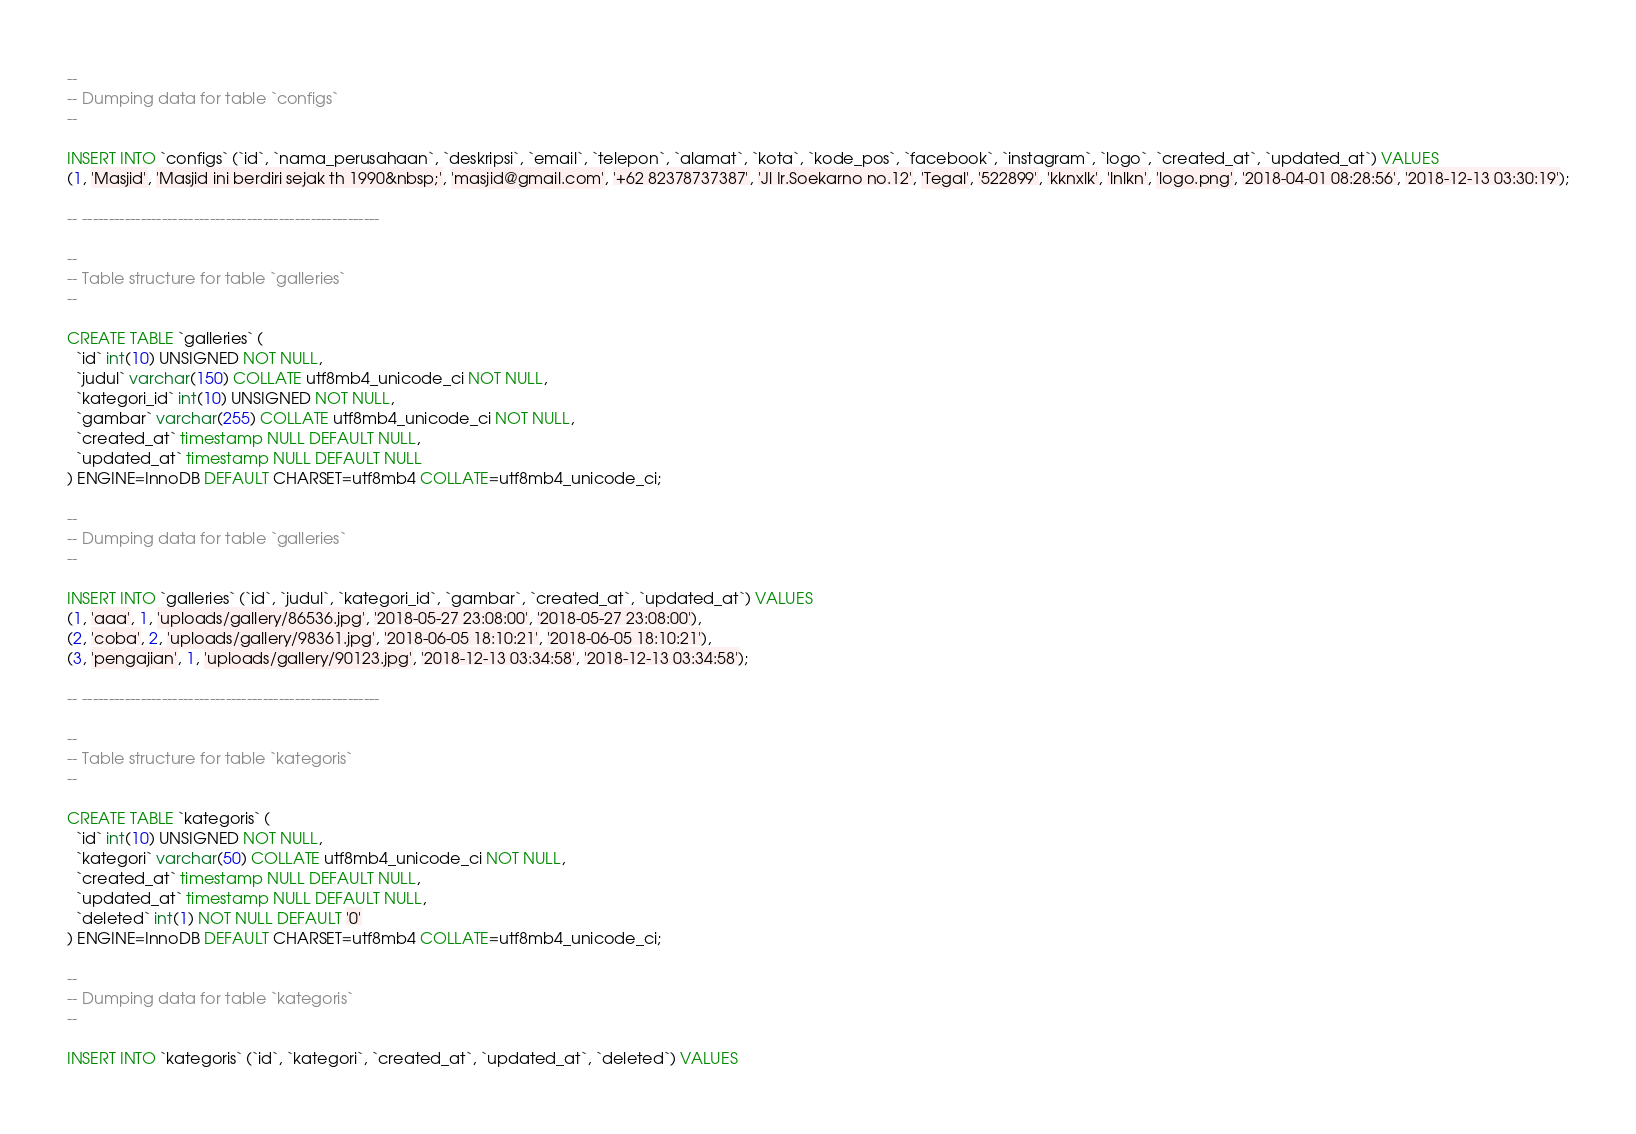<code> <loc_0><loc_0><loc_500><loc_500><_SQL_>
--
-- Dumping data for table `configs`
--

INSERT INTO `configs` (`id`, `nama_perusahaan`, `deskripsi`, `email`, `telepon`, `alamat`, `kota`, `kode_pos`, `facebook`, `instagram`, `logo`, `created_at`, `updated_at`) VALUES
(1, 'Masjid', 'Masjid ini berdiri sejak th 1990&nbsp;', 'masjid@gmail.com', '+62 82378737387', 'Jl Ir.Soekarno no.12', 'Tegal', '522899', 'kknxlk', 'lnlkn', 'logo.png', '2018-04-01 08:28:56', '2018-12-13 03:30:19');

-- --------------------------------------------------------

--
-- Table structure for table `galleries`
--

CREATE TABLE `galleries` (
  `id` int(10) UNSIGNED NOT NULL,
  `judul` varchar(150) COLLATE utf8mb4_unicode_ci NOT NULL,
  `kategori_id` int(10) UNSIGNED NOT NULL,
  `gambar` varchar(255) COLLATE utf8mb4_unicode_ci NOT NULL,
  `created_at` timestamp NULL DEFAULT NULL,
  `updated_at` timestamp NULL DEFAULT NULL
) ENGINE=InnoDB DEFAULT CHARSET=utf8mb4 COLLATE=utf8mb4_unicode_ci;

--
-- Dumping data for table `galleries`
--

INSERT INTO `galleries` (`id`, `judul`, `kategori_id`, `gambar`, `created_at`, `updated_at`) VALUES
(1, 'aaa', 1, 'uploads/gallery/86536.jpg', '2018-05-27 23:08:00', '2018-05-27 23:08:00'),
(2, 'coba', 2, 'uploads/gallery/98361.jpg', '2018-06-05 18:10:21', '2018-06-05 18:10:21'),
(3, 'pengajian', 1, 'uploads/gallery/90123.jpg', '2018-12-13 03:34:58', '2018-12-13 03:34:58');

-- --------------------------------------------------------

--
-- Table structure for table `kategoris`
--

CREATE TABLE `kategoris` (
  `id` int(10) UNSIGNED NOT NULL,
  `kategori` varchar(50) COLLATE utf8mb4_unicode_ci NOT NULL,
  `created_at` timestamp NULL DEFAULT NULL,
  `updated_at` timestamp NULL DEFAULT NULL,
  `deleted` int(1) NOT NULL DEFAULT '0'
) ENGINE=InnoDB DEFAULT CHARSET=utf8mb4 COLLATE=utf8mb4_unicode_ci;

--
-- Dumping data for table `kategoris`
--

INSERT INTO `kategoris` (`id`, `kategori`, `created_at`, `updated_at`, `deleted`) VALUES</code> 